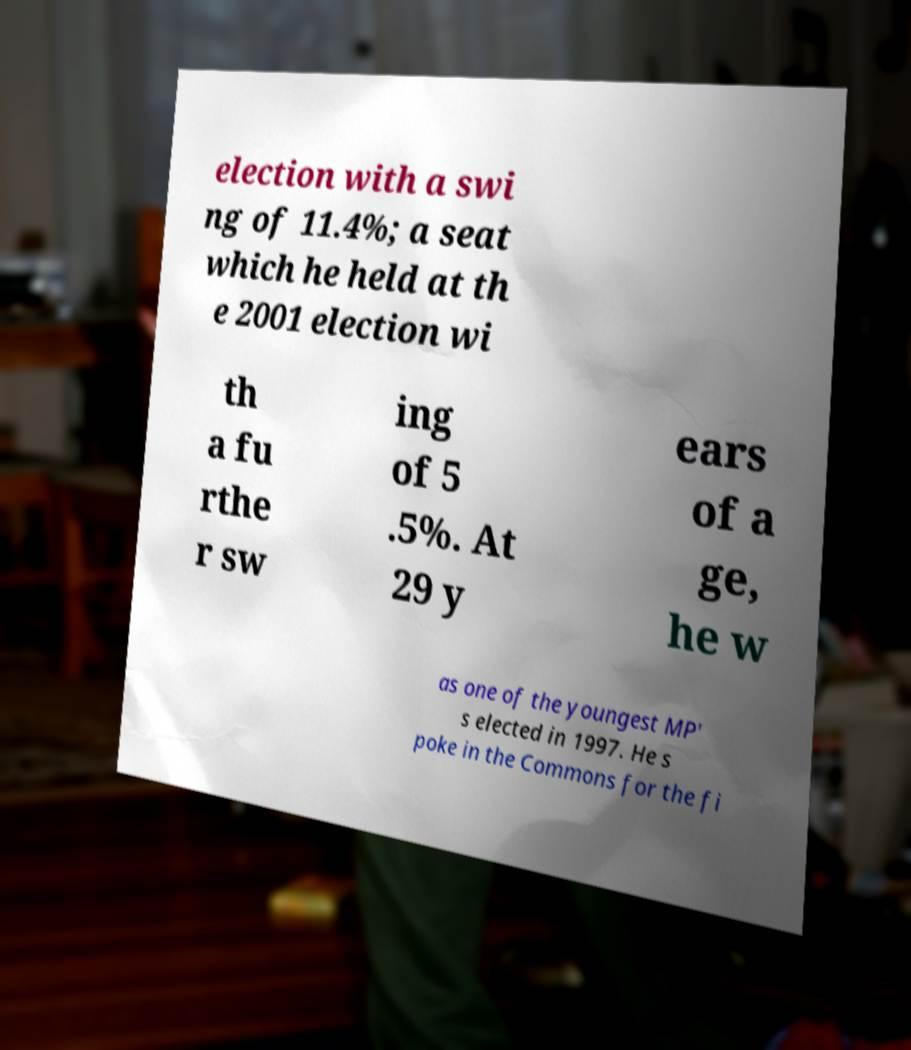Please identify and transcribe the text found in this image. election with a swi ng of 11.4%; a seat which he held at th e 2001 election wi th a fu rthe r sw ing of 5 .5%. At 29 y ears of a ge, he w as one of the youngest MP' s elected in 1997. He s poke in the Commons for the fi 